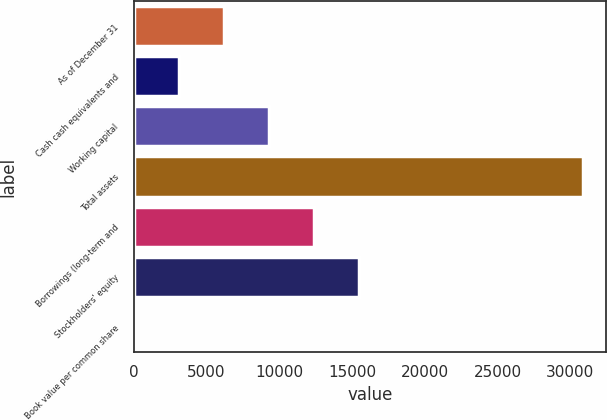<chart> <loc_0><loc_0><loc_500><loc_500><bar_chart><fcel>As of December 31<fcel>Cash cash equivalents and<fcel>Working capital<fcel>Total assets<fcel>Borrowings (long-term and<fcel>Stockholders' equity<fcel>Book value per common share<nl><fcel>6184.69<fcel>3097.53<fcel>9271.85<fcel>30882<fcel>12359<fcel>15446.2<fcel>10.37<nl></chart> 